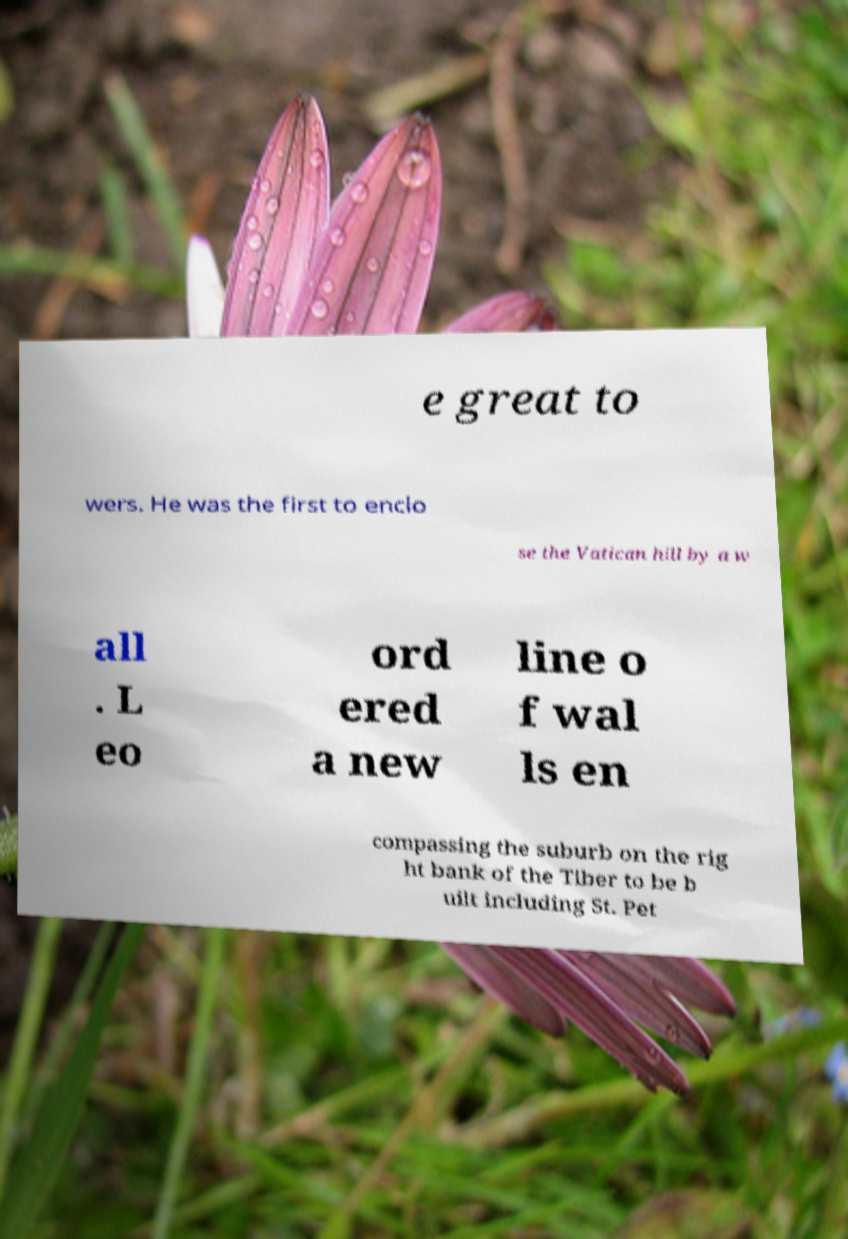There's text embedded in this image that I need extracted. Can you transcribe it verbatim? e great to wers. He was the first to enclo se the Vatican hill by a w all . L eo ord ered a new line o f wal ls en compassing the suburb on the rig ht bank of the Tiber to be b uilt including St. Pet 